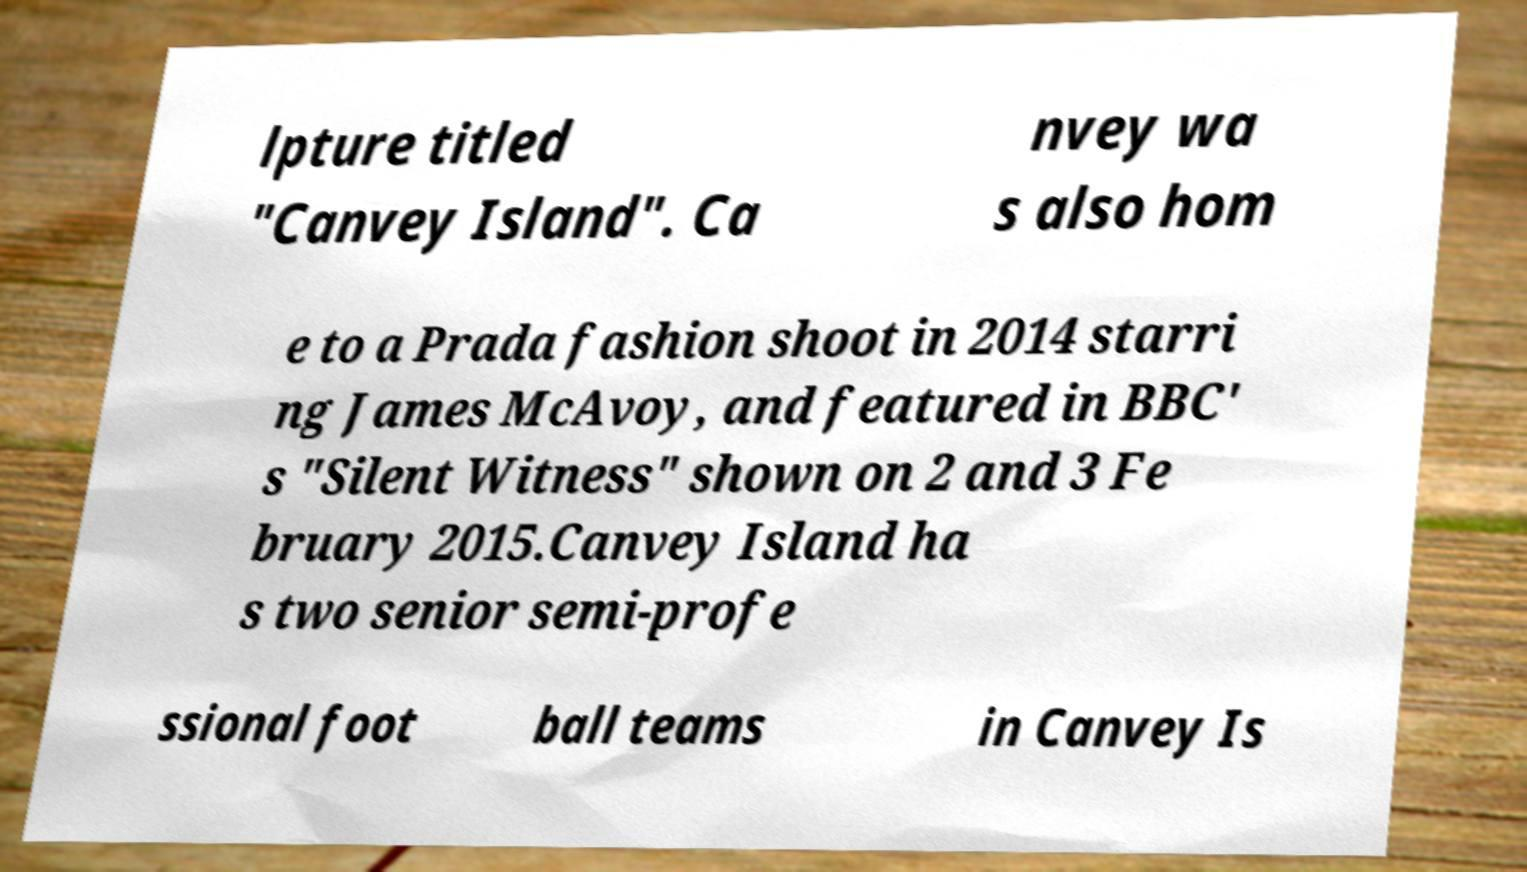Please identify and transcribe the text found in this image. lpture titled "Canvey Island". Ca nvey wa s also hom e to a Prada fashion shoot in 2014 starri ng James McAvoy, and featured in BBC' s "Silent Witness" shown on 2 and 3 Fe bruary 2015.Canvey Island ha s two senior semi-profe ssional foot ball teams in Canvey Is 